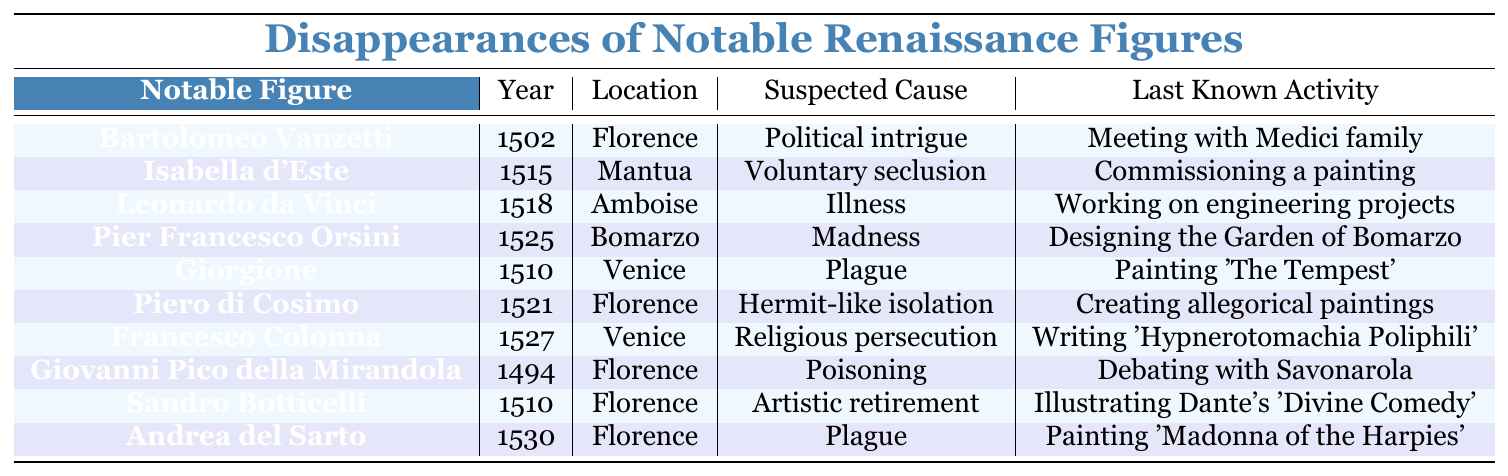What notable figure disappeared in 1525? The table shows that Pier Francesco Orsini disappeared in the year 1525.
Answer: Pier Francesco Orsini Which location had the most disappearances listed in the table? The table lists three disappearances that occurred in Florence, more than any other location.
Answer: Florence What was the suspected cause of Leonardo da Vinci's disappearance? According to the table, Leonardo da Vinci's disappearance was attributed to illness.
Answer: Illness How many individuals on the list were associated with the Plague? The table indicates that two individuals (Giorgione and Andrea del Sarto) were associated with the Plague.
Answer: Two Did any figures disappear while working on artistic projects? Yes, both Giorgione and Sandro Botticelli were involved in artistic projects at the time of their disappearance, as shown in the last known activity.
Answer: Yes What is the year of disappearance for Isabella d'Este, and what was her last known activity? Isabella d'Este disappeared in 1515, and her last known activity was commissioning a painting.
Answer: 1515; commissioning a painting Can we conclude that more figures disappeared due to illness than for voluntary seclusion? The table shows that one figure (Leonardo da Vinci) disappeared due to illness, while one figure (Isabella d'Este) disappeared due to voluntary seclusion; thus, we cannot conclude that illness caused more disappearances.
Answer: No Which notable figure was involved in political intrigue, and when did they disappear? Bartolomeo Vanzetti disappeared in 1502, and the suspected cause of his disappearance was political intrigue.
Answer: Bartolomeo Vanzetti; 1502 What would be the average year of disappearance for these notable figures? The sum of the years of disappearance (1502 + 1515 + 1518 + 1525 + 1510 + 1521 + 1527 + 1494 + 1510 + 1530) totals 15142, and there are 10 figures, so dividing gives an average of 1514.2, which rounds to 1515.
Answer: 1515 List the suspected causes of disappearance from the earliest to the latest chronologically. The table reveals the suspected causes in order: Poisoning, Political intrigue, Plague, Artistic retirement, Voluntary seclusion, Hermit-like isolation, Madness, Illness, and Religious persecution.
Answer: Poisoning, Political intrigue, Plague, Artistic retirement, Voluntary seclusion, Hermit-like isolation, Madness, Illness, Religious persecution 